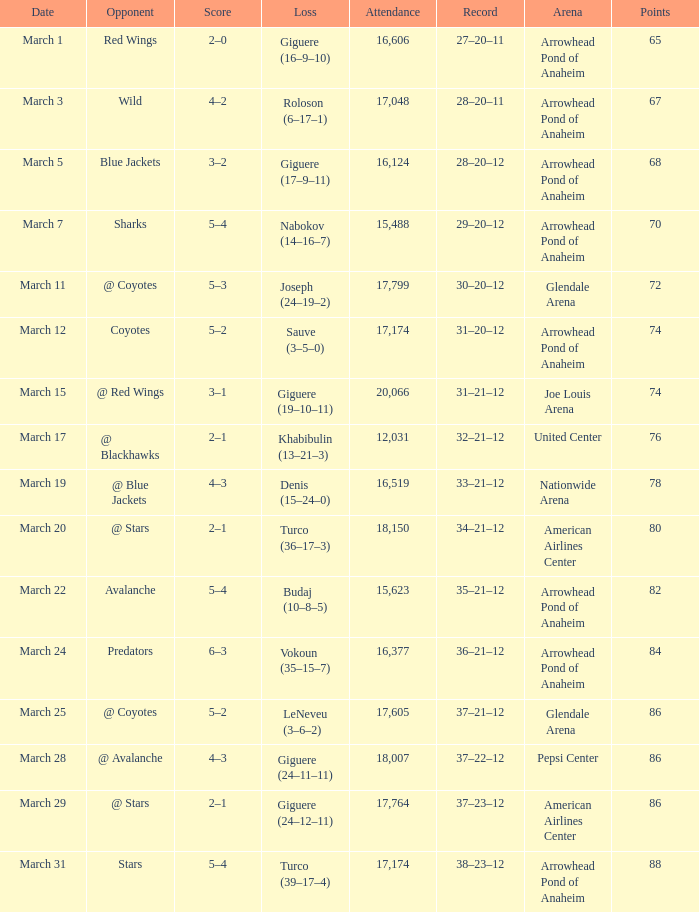What is the Attendance of the game with a Score of 3–2? 1.0. Can you give me this table as a dict? {'header': ['Date', 'Opponent', 'Score', 'Loss', 'Attendance', 'Record', 'Arena', 'Points'], 'rows': [['March 1', 'Red Wings', '2–0', 'Giguere (16–9–10)', '16,606', '27–20–11', 'Arrowhead Pond of Anaheim', '65'], ['March 3', 'Wild', '4–2', 'Roloson (6–17–1)', '17,048', '28–20–11', 'Arrowhead Pond of Anaheim', '67'], ['March 5', 'Blue Jackets', '3–2', 'Giguere (17–9–11)', '16,124', '28–20–12', 'Arrowhead Pond of Anaheim', '68'], ['March 7', 'Sharks', '5–4', 'Nabokov (14–16–7)', '15,488', '29–20–12', 'Arrowhead Pond of Anaheim', '70'], ['March 11', '@ Coyotes', '5–3', 'Joseph (24–19–2)', '17,799', '30–20–12', 'Glendale Arena', '72'], ['March 12', 'Coyotes', '5–2', 'Sauve (3–5–0)', '17,174', '31–20–12', 'Arrowhead Pond of Anaheim', '74'], ['March 15', '@ Red Wings', '3–1', 'Giguere (19–10–11)', '20,066', '31–21–12', 'Joe Louis Arena', '74'], ['March 17', '@ Blackhawks', '2–1', 'Khabibulin (13–21–3)', '12,031', '32–21–12', 'United Center', '76'], ['March 19', '@ Blue Jackets', '4–3', 'Denis (15–24–0)', '16,519', '33–21–12', 'Nationwide Arena', '78'], ['March 20', '@ Stars', '2–1', 'Turco (36–17–3)', '18,150', '34–21–12', 'American Airlines Center', '80'], ['March 22', 'Avalanche', '5–4', 'Budaj (10–8–5)', '15,623', '35–21–12', 'Arrowhead Pond of Anaheim', '82'], ['March 24', 'Predators', '6–3', 'Vokoun (35–15–7)', '16,377', '36–21–12', 'Arrowhead Pond of Anaheim', '84'], ['March 25', '@ Coyotes', '5–2', 'LeNeveu (3–6–2)', '17,605', '37–21–12', 'Glendale Arena', '86'], ['March 28', '@ Avalanche', '4–3', 'Giguere (24–11–11)', '18,007', '37–22–12', 'Pepsi Center', '86'], ['March 29', '@ Stars', '2–1', 'Giguere (24–12–11)', '17,764', '37–23–12', 'American Airlines Center', '86'], ['March 31', 'Stars', '5–4', 'Turco (39–17–4)', '17,174', '38–23–12', 'Arrowhead Pond of Anaheim', '88']]} 